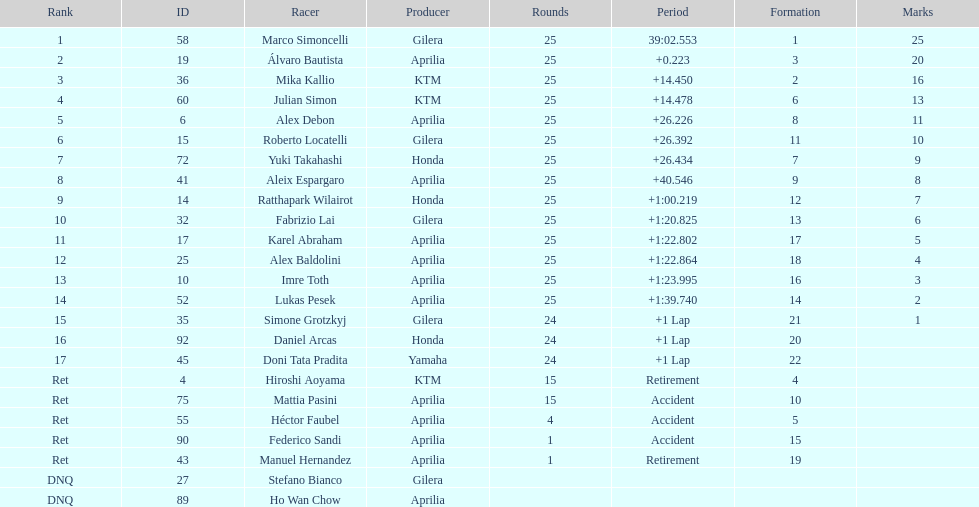The country with the most riders was Italy. 